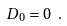<formula> <loc_0><loc_0><loc_500><loc_500>D _ { 0 } = 0 \ .</formula> 